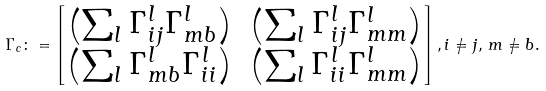Convert formula to latex. <formula><loc_0><loc_0><loc_500><loc_500>\Gamma _ { c } \colon = \begin{bmatrix} \left ( \sum _ { l } \Gamma _ { i j } ^ { l } \Gamma _ { m b } ^ { l } \right ) & \left ( \sum _ { l } \Gamma _ { i j } ^ { l } \Gamma _ { m m } ^ { l } \right ) \\ \left ( \sum _ { l } \Gamma _ { m b } ^ { l } \Gamma _ { i i } ^ { l } \right ) & \left ( \sum _ { l } \Gamma _ { i i } ^ { l } \Gamma _ { m m } ^ { l } \right ) \end{bmatrix} , i \neq j , \, m \neq b .</formula> 